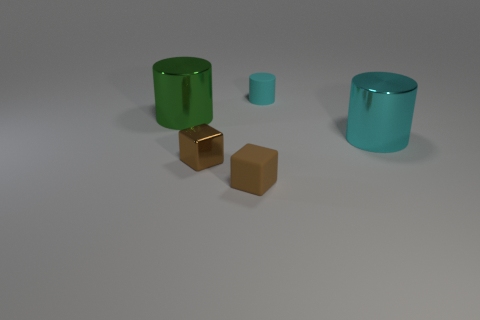Can you describe the lighting in the scene? The scene is illuminated by a soft overhead light that casts gentle shadows to the right of the objects, indicating the light source is positioned to the upper left. How does the lighting affect the appearance of the objects? The lighting highlights the contours and textures of the objects, enhances their three-dimensionality, and influences the way their colors are perceived. It also accentuates the reflective quality of the shiny surfaces. 